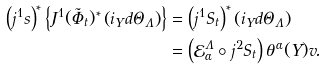<formula> <loc_0><loc_0><loc_500><loc_500>\left ( j ^ { 1 } s \right ) ^ { \ast } \left \{ J ^ { 1 } ( \tilde { \Phi } _ { t } ) ^ { \ast } \left ( i _ { Y } d \Theta _ { \Lambda } \right ) \right \} & = \left ( j ^ { 1 } S _ { t } \right ) ^ { \ast } \left ( i _ { Y } d \Theta _ { \Lambda } \right ) \\ & = \left ( \mathcal { E } _ { \alpha } ^ { \Lambda } \circ j ^ { 2 } S _ { t } \right ) \theta ^ { \alpha } ( Y ) v .</formula> 